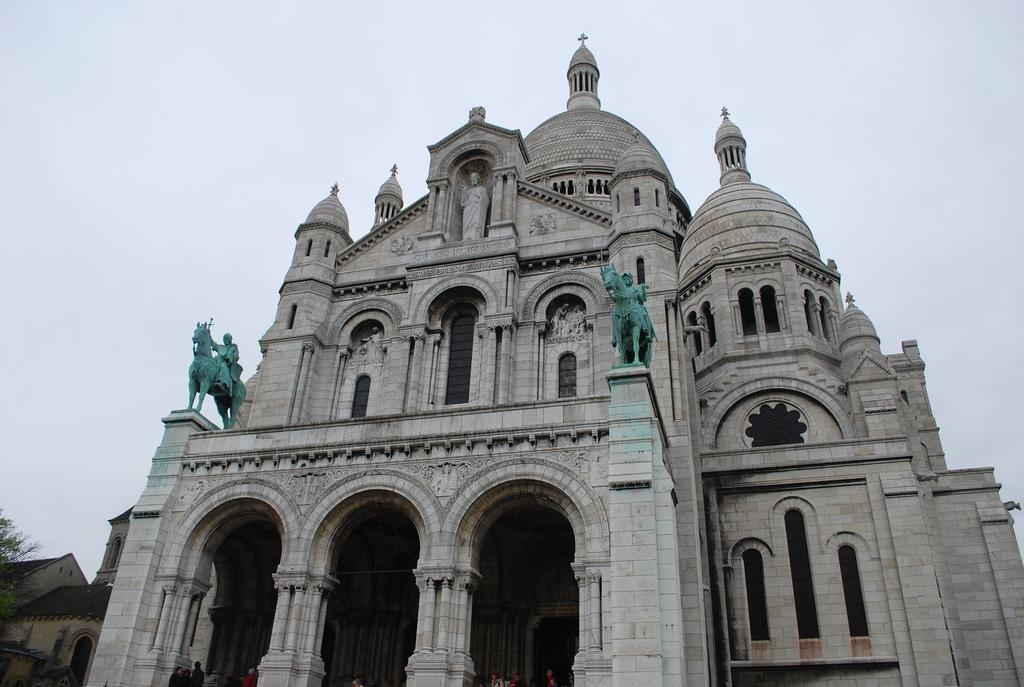What is the main subject in the center of the image? There is a monument in the center of the image. What can be seen in the bottom left side of the image? There are houses and a tree in the bottom left side of the image. What type of potato is being used to build the monument in the image? There is no potato present in the image, and the monument is not being built. 